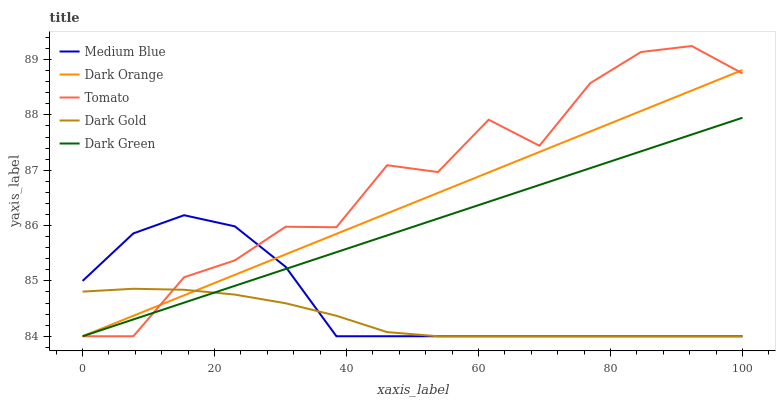Does Dark Gold have the minimum area under the curve?
Answer yes or no. Yes. Does Tomato have the maximum area under the curve?
Answer yes or no. Yes. Does Dark Orange have the minimum area under the curve?
Answer yes or no. No. Does Dark Orange have the maximum area under the curve?
Answer yes or no. No. Is Dark Orange the smoothest?
Answer yes or no. Yes. Is Tomato the roughest?
Answer yes or no. Yes. Is Dark Green the smoothest?
Answer yes or no. No. Is Dark Green the roughest?
Answer yes or no. No. Does Tomato have the lowest value?
Answer yes or no. Yes. Does Tomato have the highest value?
Answer yes or no. Yes. Does Dark Orange have the highest value?
Answer yes or no. No. Does Tomato intersect Dark Green?
Answer yes or no. Yes. Is Tomato less than Dark Green?
Answer yes or no. No. Is Tomato greater than Dark Green?
Answer yes or no. No. 